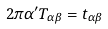Convert formula to latex. <formula><loc_0><loc_0><loc_500><loc_500>2 \pi \alpha ^ { \prime } T _ { \alpha \beta } = t _ { \alpha \beta }</formula> 